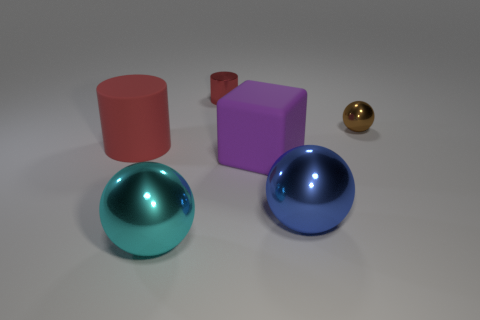What shape is the tiny thing that is behind the metal ball that is behind the big shiny thing that is behind the cyan metallic ball?
Provide a succinct answer. Cylinder. How many other objects are the same material as the blue sphere?
Offer a very short reply. 3. How many objects are metallic spheres that are right of the big blue object or metallic things?
Provide a short and direct response. 4. There is a red thing that is on the right side of the red cylinder that is in front of the brown object; what is its shape?
Your response must be concise. Cylinder. Do the large blue object that is in front of the big rubber cylinder and the brown shiny thing have the same shape?
Your answer should be compact. Yes. There is a metal sphere that is right of the blue metal sphere; what color is it?
Your response must be concise. Brown. How many cylinders are tiny yellow rubber objects or red rubber objects?
Offer a very short reply. 1. What size is the red thing behind the tiny object that is to the right of the blue shiny object?
Provide a succinct answer. Small. There is a big rubber cylinder; is its color the same as the small object left of the big purple cube?
Offer a very short reply. Yes. There is a large rubber cube; how many brown shiny things are in front of it?
Your answer should be very brief. 0. 